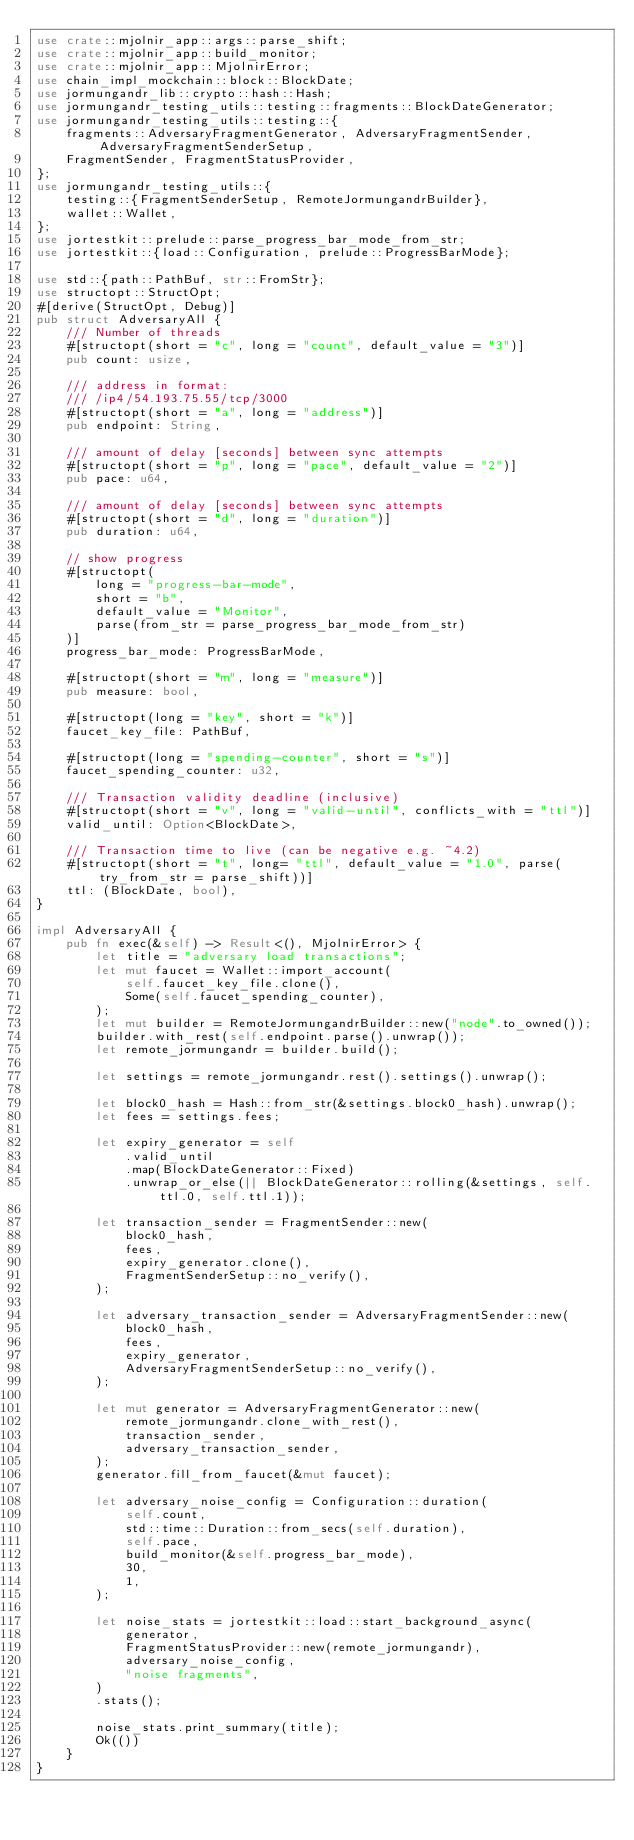Convert code to text. <code><loc_0><loc_0><loc_500><loc_500><_Rust_>use crate::mjolnir_app::args::parse_shift;
use crate::mjolnir_app::build_monitor;
use crate::mjolnir_app::MjolnirError;
use chain_impl_mockchain::block::BlockDate;
use jormungandr_lib::crypto::hash::Hash;
use jormungandr_testing_utils::testing::fragments::BlockDateGenerator;
use jormungandr_testing_utils::testing::{
    fragments::AdversaryFragmentGenerator, AdversaryFragmentSender, AdversaryFragmentSenderSetup,
    FragmentSender, FragmentStatusProvider,
};
use jormungandr_testing_utils::{
    testing::{FragmentSenderSetup, RemoteJormungandrBuilder},
    wallet::Wallet,
};
use jortestkit::prelude::parse_progress_bar_mode_from_str;
use jortestkit::{load::Configuration, prelude::ProgressBarMode};

use std::{path::PathBuf, str::FromStr};
use structopt::StructOpt;
#[derive(StructOpt, Debug)]
pub struct AdversaryAll {
    /// Number of threads
    #[structopt(short = "c", long = "count", default_value = "3")]
    pub count: usize,

    /// address in format:
    /// /ip4/54.193.75.55/tcp/3000
    #[structopt(short = "a", long = "address")]
    pub endpoint: String,

    /// amount of delay [seconds] between sync attempts
    #[structopt(short = "p", long = "pace", default_value = "2")]
    pub pace: u64,

    /// amount of delay [seconds] between sync attempts
    #[structopt(short = "d", long = "duration")]
    pub duration: u64,

    // show progress
    #[structopt(
        long = "progress-bar-mode",
        short = "b",
        default_value = "Monitor",
        parse(from_str = parse_progress_bar_mode_from_str)
    )]
    progress_bar_mode: ProgressBarMode,

    #[structopt(short = "m", long = "measure")]
    pub measure: bool,

    #[structopt(long = "key", short = "k")]
    faucet_key_file: PathBuf,

    #[structopt(long = "spending-counter", short = "s")]
    faucet_spending_counter: u32,

    /// Transaction validity deadline (inclusive)
    #[structopt(short = "v", long = "valid-until", conflicts_with = "ttl")]
    valid_until: Option<BlockDate>,

    /// Transaction time to live (can be negative e.g. ~4.2)
    #[structopt(short = "t", long= "ttl", default_value = "1.0", parse(try_from_str = parse_shift))]
    ttl: (BlockDate, bool),
}

impl AdversaryAll {
    pub fn exec(&self) -> Result<(), MjolnirError> {
        let title = "adversary load transactions";
        let mut faucet = Wallet::import_account(
            self.faucet_key_file.clone(),
            Some(self.faucet_spending_counter),
        );
        let mut builder = RemoteJormungandrBuilder::new("node".to_owned());
        builder.with_rest(self.endpoint.parse().unwrap());
        let remote_jormungandr = builder.build();

        let settings = remote_jormungandr.rest().settings().unwrap();

        let block0_hash = Hash::from_str(&settings.block0_hash).unwrap();
        let fees = settings.fees;

        let expiry_generator = self
            .valid_until
            .map(BlockDateGenerator::Fixed)
            .unwrap_or_else(|| BlockDateGenerator::rolling(&settings, self.ttl.0, self.ttl.1));

        let transaction_sender = FragmentSender::new(
            block0_hash,
            fees,
            expiry_generator.clone(),
            FragmentSenderSetup::no_verify(),
        );

        let adversary_transaction_sender = AdversaryFragmentSender::new(
            block0_hash,
            fees,
            expiry_generator,
            AdversaryFragmentSenderSetup::no_verify(),
        );

        let mut generator = AdversaryFragmentGenerator::new(
            remote_jormungandr.clone_with_rest(),
            transaction_sender,
            adversary_transaction_sender,
        );
        generator.fill_from_faucet(&mut faucet);

        let adversary_noise_config = Configuration::duration(
            self.count,
            std::time::Duration::from_secs(self.duration),
            self.pace,
            build_monitor(&self.progress_bar_mode),
            30,
            1,
        );

        let noise_stats = jortestkit::load::start_background_async(
            generator,
            FragmentStatusProvider::new(remote_jormungandr),
            adversary_noise_config,
            "noise fragments",
        )
        .stats();

        noise_stats.print_summary(title);
        Ok(())
    }
}
</code> 